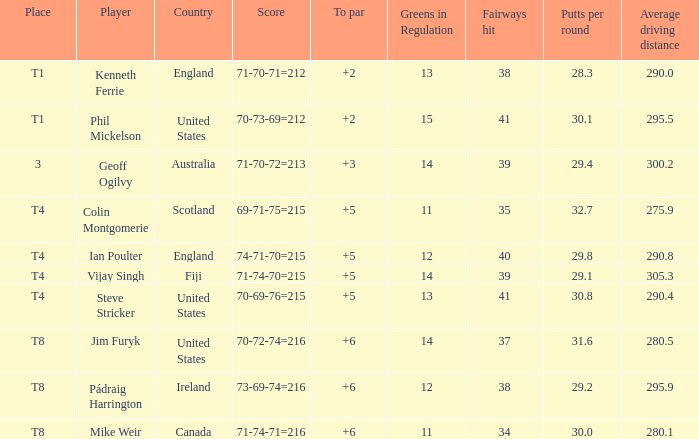What score to par did Mike Weir have? 6.0. Could you parse the entire table as a dict? {'header': ['Place', 'Player', 'Country', 'Score', 'To par', 'Greens in Regulation', 'Fairways hit', 'Putts per round', 'Average driving distance'], 'rows': [['T1', 'Kenneth Ferrie', 'England', '71-70-71=212', '+2', '13', '38', '28.3', '290.0'], ['T1', 'Phil Mickelson', 'United States', '70-73-69=212', '+2', '15', '41', '30.1', '295.5'], ['3', 'Geoff Ogilvy', 'Australia', '71-70-72=213', '+3', '14', '39', '29.4', '300.2'], ['T4', 'Colin Montgomerie', 'Scotland', '69-71-75=215', '+5', '11', '35', '32.7', '275.9'], ['T4', 'Ian Poulter', 'England', '74-71-70=215', '+5', '12', '40', '29.8', '290.8'], ['T4', 'Vijay Singh', 'Fiji', '71-74-70=215', '+5', '14', '39', '29.1', '305.3'], ['T4', 'Steve Stricker', 'United States', '70-69-76=215', '+5', '13', '41', '30.8', '290.4'], ['T8', 'Jim Furyk', 'United States', '70-72-74=216', '+6', '14', '37', '31.6', '280.5'], ['T8', 'Pádraig Harrington', 'Ireland', '73-69-74=216', '+6', '12', '38', '29.2', '295.9'], ['T8', 'Mike Weir', 'Canada', '71-74-71=216', '+6', '11', '34', '30.0', '280.1']]} 